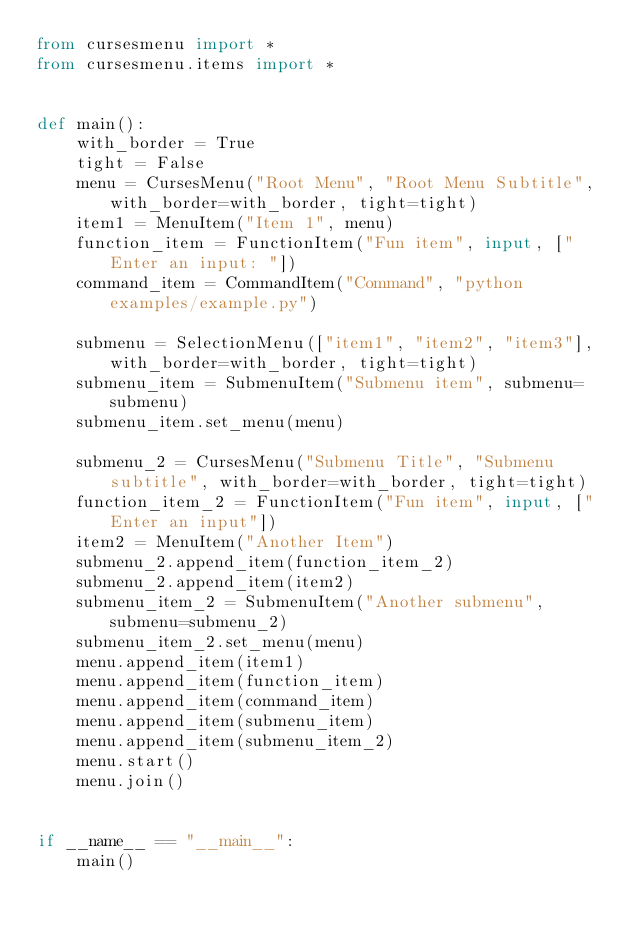Convert code to text. <code><loc_0><loc_0><loc_500><loc_500><_Python_>from cursesmenu import *
from cursesmenu.items import *


def main():
    with_border = True
    tight = False
    menu = CursesMenu("Root Menu", "Root Menu Subtitle", with_border=with_border, tight=tight)
    item1 = MenuItem("Item 1", menu)
    function_item = FunctionItem("Fun item", input, ["Enter an input: "])
    command_item = CommandItem("Command", "python examples/example.py")

    submenu = SelectionMenu(["item1", "item2", "item3"], with_border=with_border, tight=tight)
    submenu_item = SubmenuItem("Submenu item", submenu=submenu)
    submenu_item.set_menu(menu)

    submenu_2 = CursesMenu("Submenu Title", "Submenu subtitle", with_border=with_border, tight=tight)
    function_item_2 = FunctionItem("Fun item", input, ["Enter an input"])
    item2 = MenuItem("Another Item")
    submenu_2.append_item(function_item_2)
    submenu_2.append_item(item2)
    submenu_item_2 = SubmenuItem("Another submenu", submenu=submenu_2)
    submenu_item_2.set_menu(menu)
    menu.append_item(item1)
    menu.append_item(function_item)
    menu.append_item(command_item)
    menu.append_item(submenu_item)
    menu.append_item(submenu_item_2)
    menu.start()
    menu.join()


if __name__ == "__main__":
    main()
</code> 